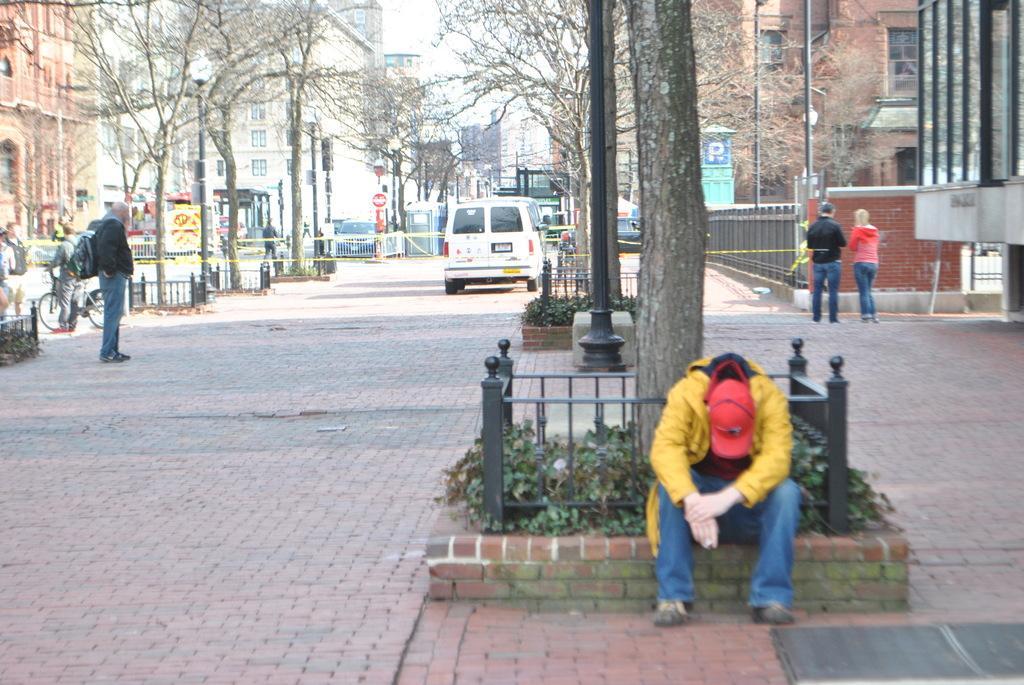Please provide a concise description of this image. In this picture we can see a person is sitting on the path and behind the person there are poles and on the left and right side of the person there are some people standing on the path. Behind the people there are trees, fences, some vehicles on the path, buildings and a sky. 